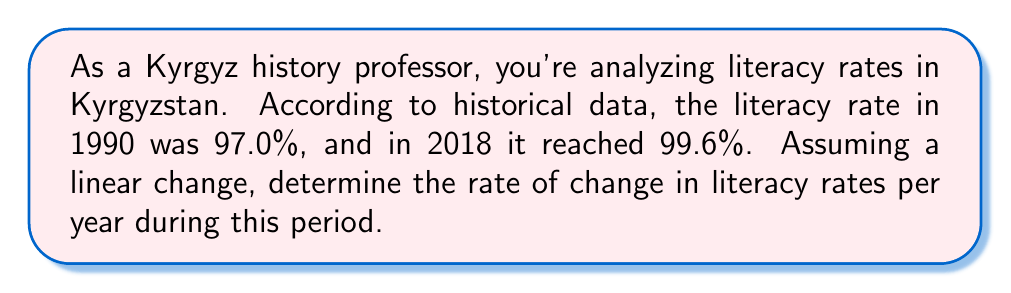Could you help me with this problem? To solve this problem, we need to use the concept of rate of change in a linear equation. The rate of change is the slope of the line, which can be calculated using the formula:

$$ \text{Rate of change} = \frac{\text{Change in y}}{\text{Change in x}} = \frac{y_2 - y_1}{x_2 - x_1} $$

Where:
- $y_2$ is the final literacy rate (99.6%)
- $y_1$ is the initial literacy rate (97.0%)
- $x_2$ is the final year (2018)
- $x_1$ is the initial year (1990)

Let's plug these values into the formula:

$$ \text{Rate of change} = \frac{99.6\% - 97.0\%}{2018 - 1990} = \frac{2.6\%}{28 \text{ years}} $$

Now, let's perform the division:

$$ \text{Rate of change} = \frac{2.6}{28} = 0.0928571429\% \text{ per year} $$

To express this as a percentage with four decimal places, we round the result:

$$ \text{Rate of change} \approx 0.0929\% \text{ per year} $$

This means that, on average, the literacy rate in Kyrgyzstan increased by approximately 0.0929% each year between 1990 and 2018, assuming a linear change.
Answer: The rate of change in literacy rates in Kyrgyzstan from 1990 to 2018 is approximately $0.0929\%$ per year. 